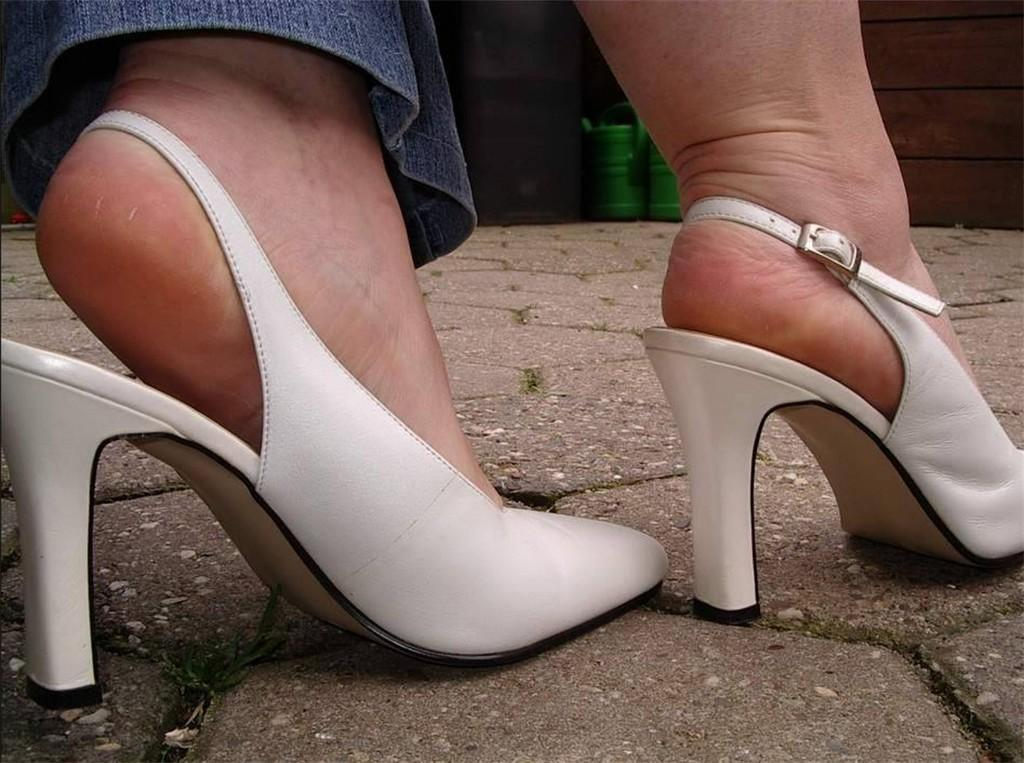What type of footwear is visible in the image? There are heels of a woman in the image. Can you describe the legs wearing the heels? There are legs wearing the heels in the image. What objects can be seen in the background of the image? In the background, there are two drums on the floor. How many icicles are hanging from the woman's heels in the image? There are no icicles present in the image. What type of yard can be seen in the background of the image? There is no yard visible in the image; it only shows a woman's legs wearing heels and two drums in the background. 